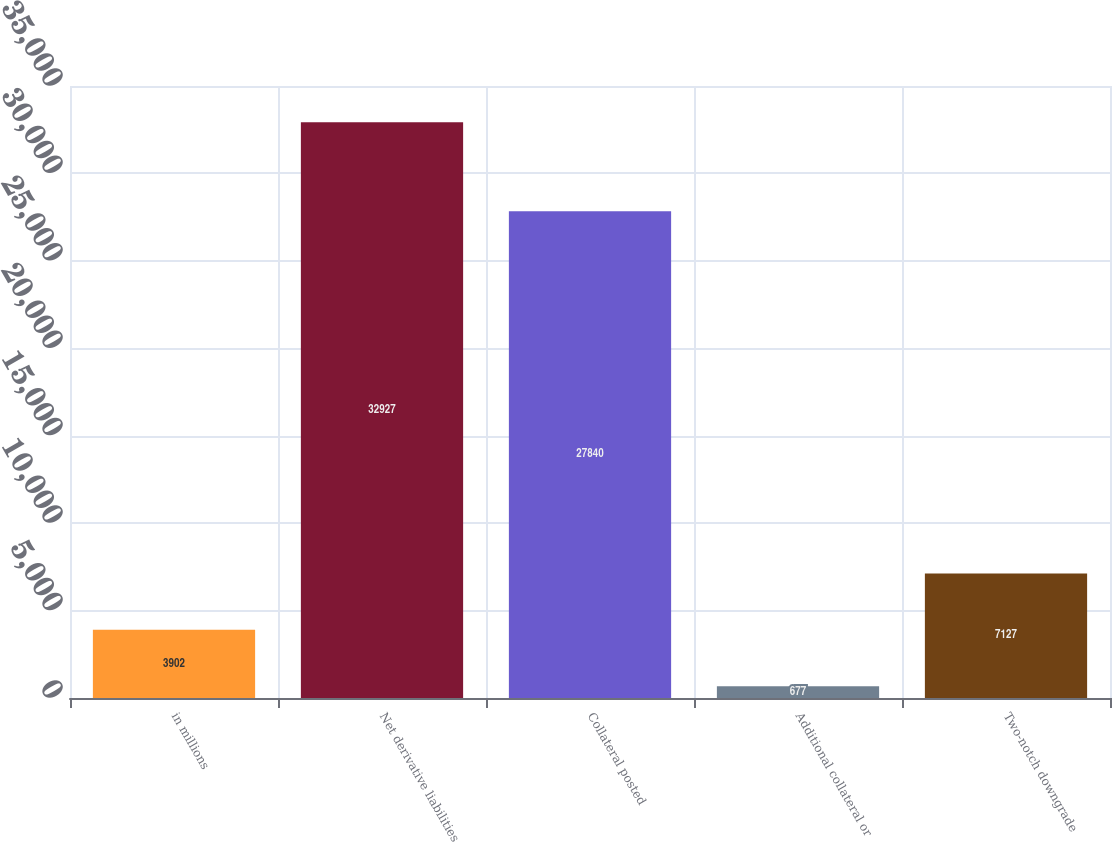Convert chart. <chart><loc_0><loc_0><loc_500><loc_500><bar_chart><fcel>in millions<fcel>Net derivative liabilities<fcel>Collateral posted<fcel>Additional collateral or<fcel>Two-notch downgrade<nl><fcel>3902<fcel>32927<fcel>27840<fcel>677<fcel>7127<nl></chart> 